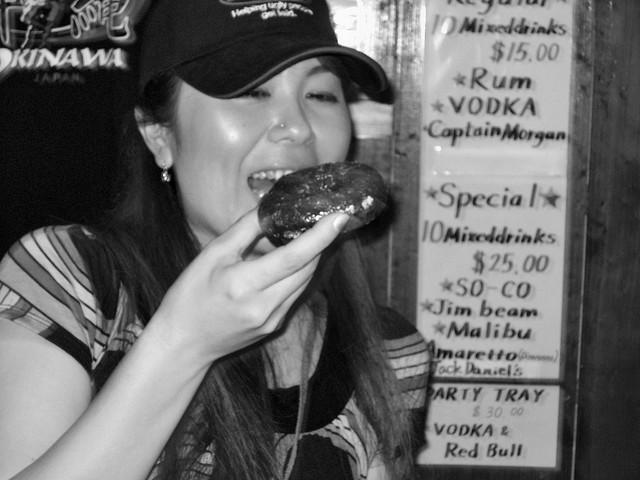What design is on the woman's top?
Keep it brief. Stripes. Does the establishment serve drinks?
Quick response, please. Yes. What is the lady eating?
Concise answer only. Donut. 